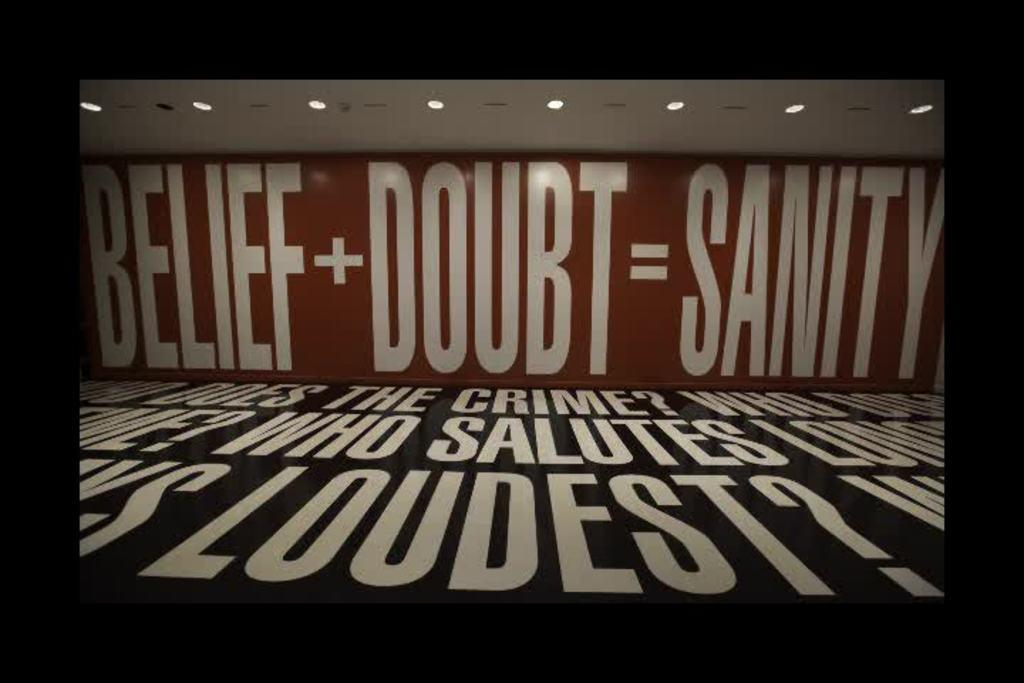Provide a one-sentence caption for the provided image. The sign has wording on it that says BELIEF + DOUBT = SANITY. 